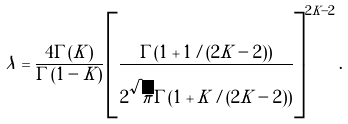<formula> <loc_0><loc_0><loc_500><loc_500>\lambda = \frac { 4 \Gamma ( K ) } { \Gamma ( 1 - K ) } \left [ \frac { \Gamma ( 1 + 1 / ( 2 K - 2 ) ) } { 2 \sqrt { \pi } \Gamma ( 1 + K / ( 2 K - 2 ) ) } \right ] ^ { 2 K - 2 } .</formula> 